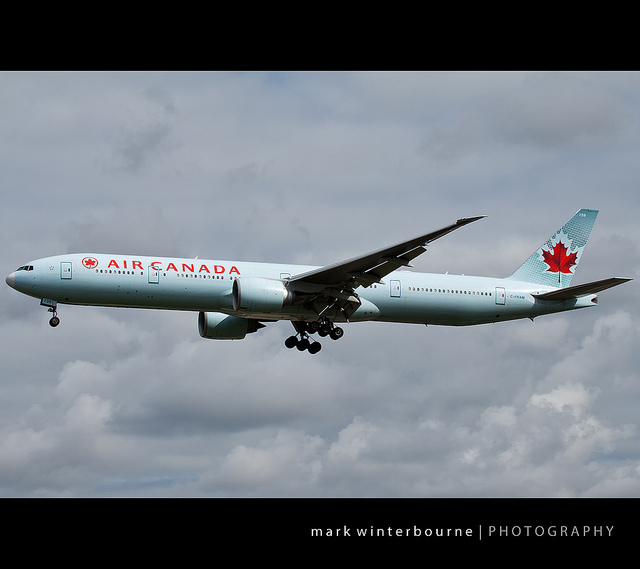Please extract the text content from this image. AIR CANADA PHOTOGRAPHY winterbourne mark 